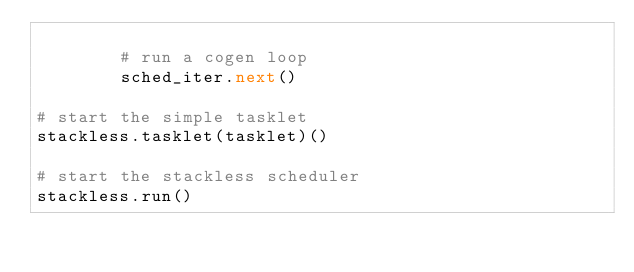<code> <loc_0><loc_0><loc_500><loc_500><_Python_>
        # run a cogen loop
        sched_iter.next()

# start the simple tasklet
stackless.tasklet(tasklet)()

# start the stackless scheduler
stackless.run()
</code> 